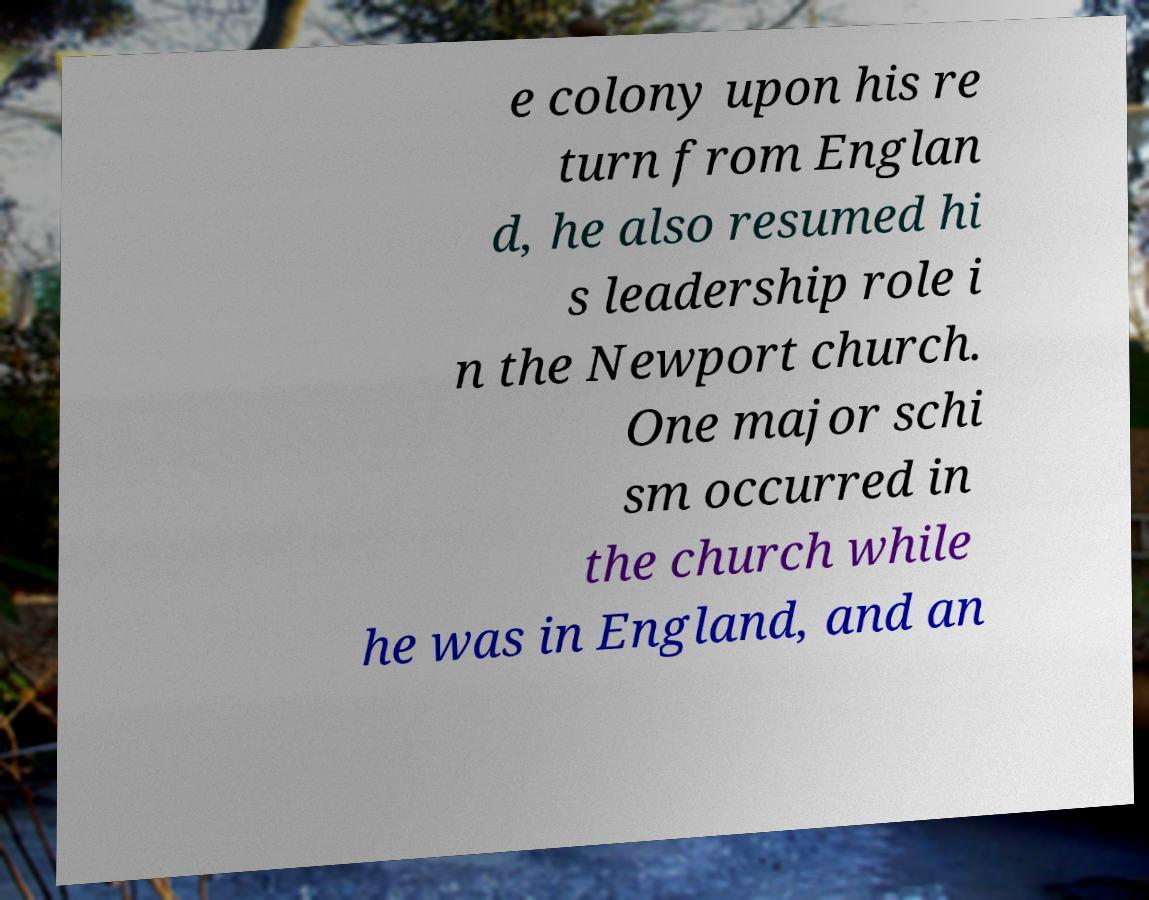Can you accurately transcribe the text from the provided image for me? e colony upon his re turn from Englan d, he also resumed hi s leadership role i n the Newport church. One major schi sm occurred in the church while he was in England, and an 